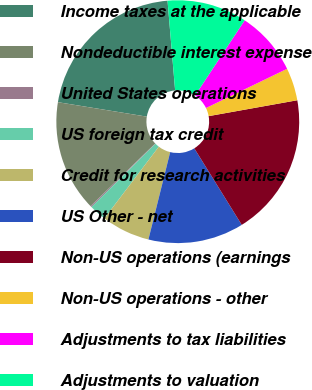Convert chart. <chart><loc_0><loc_0><loc_500><loc_500><pie_chart><fcel>Income taxes at the applicable<fcel>Nondeductible interest expense<fcel>United States operations<fcel>US foreign tax credit<fcel>Credit for research activities<fcel>US Other - net<fcel>Non-US operations (earnings<fcel>Non-US operations - other<fcel>Adjustments to tax liabilities<fcel>Adjustments to valuation<nl><fcel>21.09%<fcel>14.81%<fcel>0.17%<fcel>2.26%<fcel>6.44%<fcel>12.72%<fcel>18.99%<fcel>4.35%<fcel>8.54%<fcel>10.63%<nl></chart> 